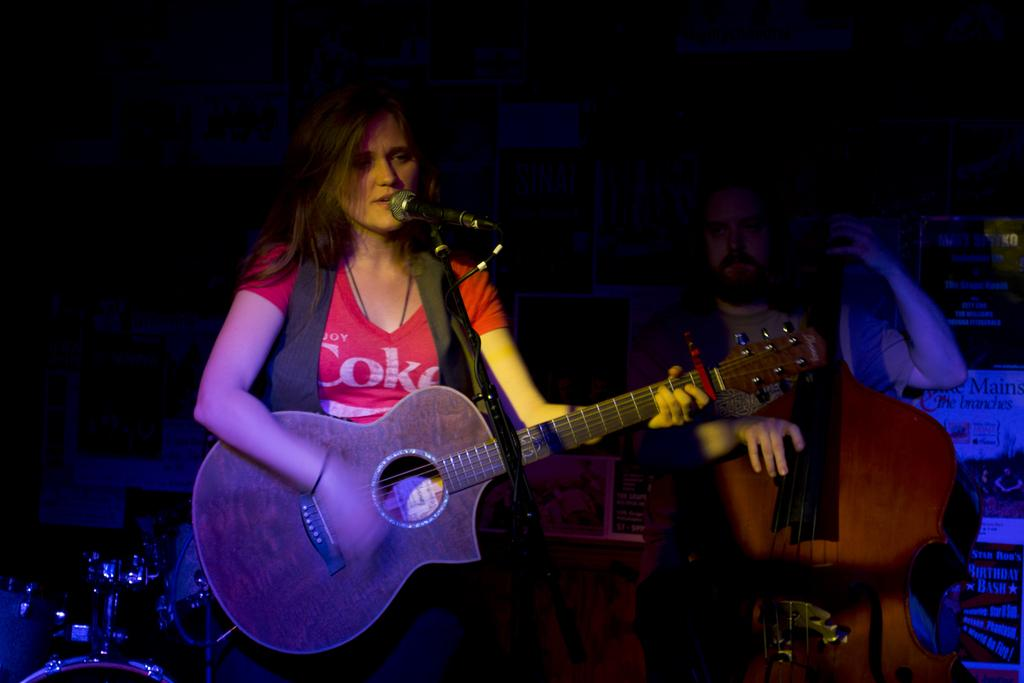What is the woman in the image doing? The woman is playing a guitar in the image. What is the woman standing in front of? The woman is standing in front of a mic and a stand in the image. Are there any other people in the image? Yes, there is another person in the image. What is the other person doing? The other person is playing a guitar in the background. What type of detail can be seen on the spade in the image? There is no spade present in the image; it features a woman and another person playing guitars in front of a mic and a stand. 